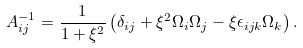<formula> <loc_0><loc_0><loc_500><loc_500>A _ { i j } ^ { - 1 } = \frac { 1 } { 1 + \xi ^ { 2 } } \left ( \delta _ { i j } + \xi ^ { 2 } \Omega _ { i } \Omega _ { j } - \xi \epsilon _ { i j k } \Omega _ { k } \right ) .</formula> 